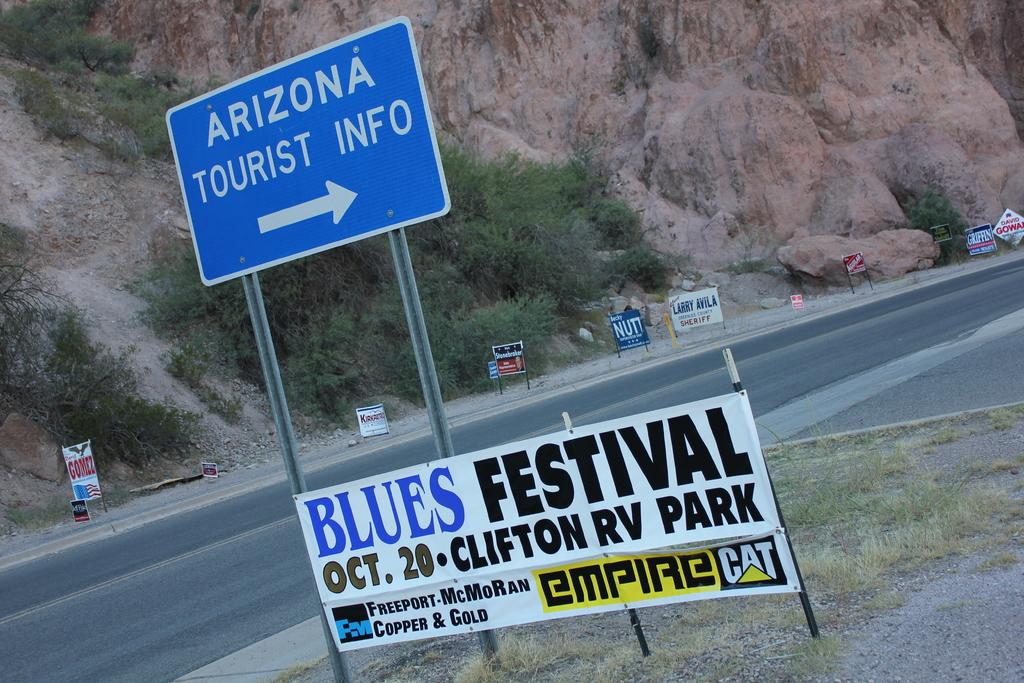<image>
Summarize the visual content of the image. A sign posted by the highway promoting a "Blues Festival". 